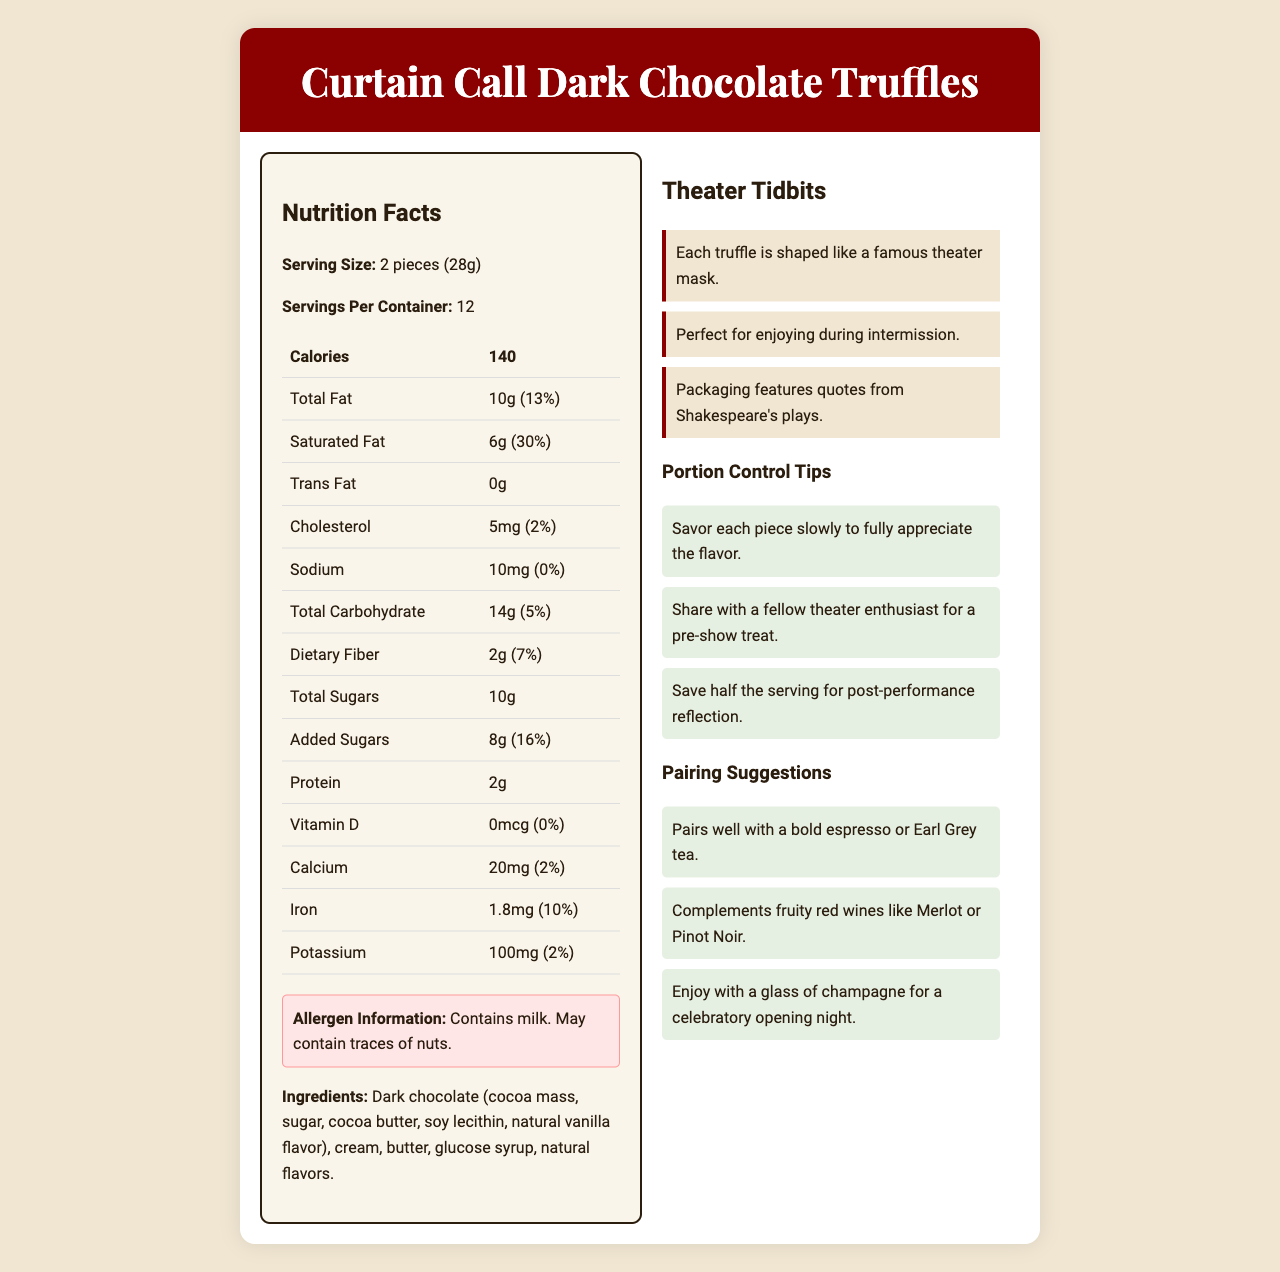what is the serving size for Curtain Call Dark Chocolate Truffles? The serving size for the product is clearly listed in the "Nutrition Facts" section of the document.
Answer: 2 pieces (28g) how many servings are there per container? The document states that there are 12 servings per container.
Answer: 12 how many calories are in one serving of the truffles? The "Nutrition Facts" section indicates that each serving contains 140 calories.
Answer: 140 how much total fat does one serving of the truffles contain? The total fat content per serving is noted as 10g in the nutrition information.
Answer: 10g what percentage of the daily value of saturated fat is in one serving? The daily value percentage for saturated fat per serving is 30% as mentioned in the document.
Answer: 30% does the product contain any trans fat? According to the nutrition facts, the truffles contain 0g of trans fat.
Answer: No how much dietary fiber is in one serving? The dietary fiber content per serving is 2g as indicated in the nutrition statistics.
Answer: 2g how much added sugar do the truffles contain per serving? A. 6g B. 8g C. 10g D. 12g The "Added Sugars" section of the nutrition facts lists the amount as 8g per serving.
Answer: B what vitamin percentage is provided by the truffles? A. Vitamin A B. Vitamin B6 C. Vitamin D D. Vitamin C The document lists Vitamin D with an amount of 0mcg and a 0% daily value.
Answer: C is there any cholesterol in one serving of the truffles? The document mentions that each serving contains 5mg of cholesterol.
Answer: Yes what is one of the portion control tips provided in the document? The "Portion Control Tips" section advises this as one of the recommendations.
Answer: Savor each piece slowly to fully appreciate the flavor. which beverages are suggested to pair with the truffles? The "Pairing Suggestions" section includes bold espresso or Earl Grey tea as options to pair with the truffles.
Answer: Bold espresso or Earl Grey tea describe the allergen information provided in the document. The document clearly states that the product contains milk and may contain traces of nuts.
Answer: Contains milk. May contain traces of nuts. explain the main idea of the document. The document is designed to offer comprehensive information about the chocolate truffles, emphasizing their nutritional content, ideal consumption practices, and enjoyable pairings, all while integrating a theater motif.
Answer: The document provides detailed nutritional information for Curtain Call Dark Chocolate Truffles, along with portion control tips, pairing suggestions, and interesting theater-themed facts. It also highlights allergen information and ingredients. how many grams of protein are in one serving of truffles? The document lists the protein content per serving as 2g.
Answer: 2g how much iron is in one serving of the truffles? The nutrition facts list the amount of iron per serving as 1.8mg.
Answer: 1.8mg is there any calcium in the truffles? The truffles contain 20mg of calcium per serving according to the nutrition facts.
Answer: Yes what are the ingredients listed for the truffles? The document provides a detailed list of ingredients used in the truffles.
Answer: Dark chocolate (cocoa mass, sugar, cocoa butter, soy lecithin, natural vanilla flavor), cream, butter, glucose syrup, natural flavors. what is the exact amount of potassium in one serving? The nutrition facts section specifies that each serving contains 100mg of potassium.
Answer: 100mg can the nutritional information about sugars be sufficient for someone with diabetes to decide their intake? The nutritional information does provide data on total and added sugars per serving, but someone with diabetes may need more specific guidance or additional context to make an informed decision.
Answer: Not enough information who might enjoy the theater facts provided in the document? The theater facts section contains quotes from Shakespeare's plays and notes that each truffle is shaped like a famous theater mask, which would appeal to theater lovers.
Answer: Theater enthusiasts or people with an interest in Shakespeare. 